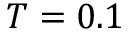<formula> <loc_0><loc_0><loc_500><loc_500>T = 0 . 1</formula> 